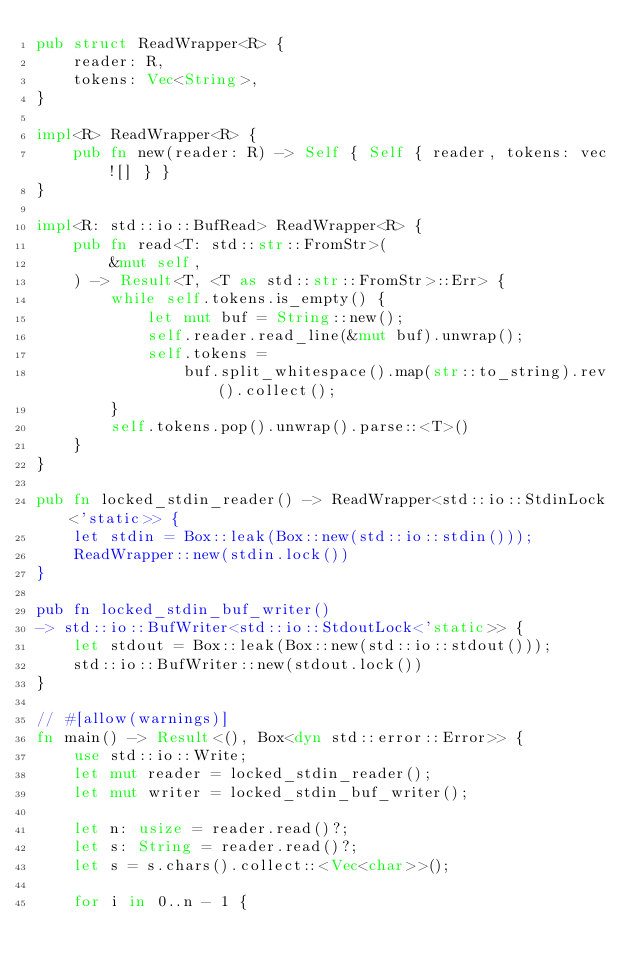<code> <loc_0><loc_0><loc_500><loc_500><_Rust_>pub struct ReadWrapper<R> {
    reader: R,
    tokens: Vec<String>,
}

impl<R> ReadWrapper<R> {
    pub fn new(reader: R) -> Self { Self { reader, tokens: vec![] } }
}

impl<R: std::io::BufRead> ReadWrapper<R> {
    pub fn read<T: std::str::FromStr>(
        &mut self,
    ) -> Result<T, <T as std::str::FromStr>::Err> {
        while self.tokens.is_empty() {
            let mut buf = String::new();
            self.reader.read_line(&mut buf).unwrap();
            self.tokens =
                buf.split_whitespace().map(str::to_string).rev().collect();
        }
        self.tokens.pop().unwrap().parse::<T>()
    }
}

pub fn locked_stdin_reader() -> ReadWrapper<std::io::StdinLock<'static>> {
    let stdin = Box::leak(Box::new(std::io::stdin()));
    ReadWrapper::new(stdin.lock())
}

pub fn locked_stdin_buf_writer()
-> std::io::BufWriter<std::io::StdoutLock<'static>> {
    let stdout = Box::leak(Box::new(std::io::stdout()));
    std::io::BufWriter::new(stdout.lock())
}

// #[allow(warnings)]
fn main() -> Result<(), Box<dyn std::error::Error>> {
    use std::io::Write;
    let mut reader = locked_stdin_reader();
    let mut writer = locked_stdin_buf_writer();

    let n: usize = reader.read()?;
    let s: String = reader.read()?;
    let s = s.chars().collect::<Vec<char>>();

    for i in 0..n - 1 {</code> 